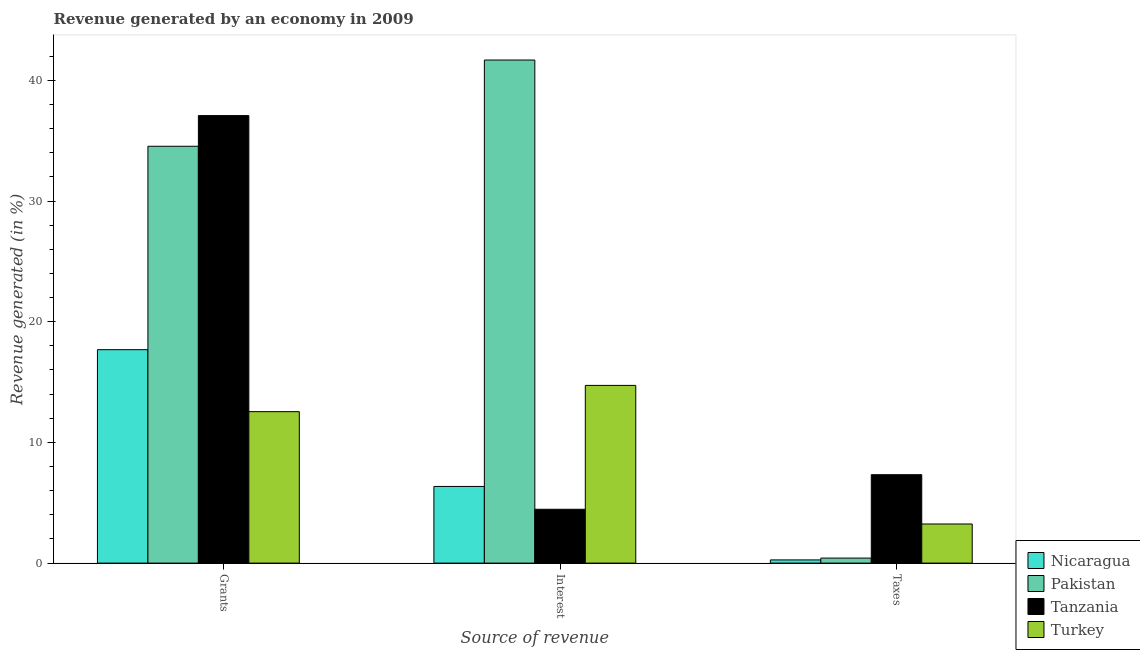How many different coloured bars are there?
Provide a succinct answer. 4. Are the number of bars per tick equal to the number of legend labels?
Your answer should be very brief. Yes. Are the number of bars on each tick of the X-axis equal?
Keep it short and to the point. Yes. How many bars are there on the 3rd tick from the right?
Your answer should be compact. 4. What is the label of the 3rd group of bars from the left?
Ensure brevity in your answer.  Taxes. What is the percentage of revenue generated by taxes in Tanzania?
Your response must be concise. 7.33. Across all countries, what is the maximum percentage of revenue generated by taxes?
Provide a succinct answer. 7.33. Across all countries, what is the minimum percentage of revenue generated by grants?
Provide a succinct answer. 12.55. In which country was the percentage of revenue generated by grants minimum?
Offer a terse response. Turkey. What is the total percentage of revenue generated by interest in the graph?
Keep it short and to the point. 67.22. What is the difference between the percentage of revenue generated by grants in Tanzania and that in Turkey?
Ensure brevity in your answer.  24.53. What is the difference between the percentage of revenue generated by interest in Pakistan and the percentage of revenue generated by taxes in Nicaragua?
Your response must be concise. 41.41. What is the average percentage of revenue generated by interest per country?
Give a very brief answer. 16.8. What is the difference between the percentage of revenue generated by interest and percentage of revenue generated by grants in Pakistan?
Your answer should be compact. 7.14. What is the ratio of the percentage of revenue generated by taxes in Nicaragua to that in Tanzania?
Ensure brevity in your answer.  0.04. Is the percentage of revenue generated by grants in Tanzania less than that in Pakistan?
Provide a short and direct response. No. Is the difference between the percentage of revenue generated by taxes in Turkey and Tanzania greater than the difference between the percentage of revenue generated by interest in Turkey and Tanzania?
Ensure brevity in your answer.  No. What is the difference between the highest and the second highest percentage of revenue generated by taxes?
Keep it short and to the point. 4.08. What is the difference between the highest and the lowest percentage of revenue generated by interest?
Provide a succinct answer. 37.22. Is the sum of the percentage of revenue generated by interest in Turkey and Nicaragua greater than the maximum percentage of revenue generated by grants across all countries?
Provide a succinct answer. No. What does the 1st bar from the left in Taxes represents?
Make the answer very short. Nicaragua. What does the 4th bar from the right in Interest represents?
Keep it short and to the point. Nicaragua. Is it the case that in every country, the sum of the percentage of revenue generated by grants and percentage of revenue generated by interest is greater than the percentage of revenue generated by taxes?
Your response must be concise. Yes. How many bars are there?
Provide a short and direct response. 12. Are all the bars in the graph horizontal?
Your answer should be very brief. No. How many countries are there in the graph?
Ensure brevity in your answer.  4. Does the graph contain grids?
Provide a short and direct response. No. Where does the legend appear in the graph?
Ensure brevity in your answer.  Bottom right. How are the legend labels stacked?
Ensure brevity in your answer.  Vertical. What is the title of the graph?
Make the answer very short. Revenue generated by an economy in 2009. What is the label or title of the X-axis?
Give a very brief answer. Source of revenue. What is the label or title of the Y-axis?
Provide a short and direct response. Revenue generated (in %). What is the Revenue generated (in %) of Nicaragua in Grants?
Ensure brevity in your answer.  17.68. What is the Revenue generated (in %) in Pakistan in Grants?
Provide a succinct answer. 34.54. What is the Revenue generated (in %) of Tanzania in Grants?
Your answer should be compact. 37.08. What is the Revenue generated (in %) in Turkey in Grants?
Provide a short and direct response. 12.55. What is the Revenue generated (in %) of Nicaragua in Interest?
Your answer should be very brief. 6.35. What is the Revenue generated (in %) in Pakistan in Interest?
Make the answer very short. 41.68. What is the Revenue generated (in %) of Tanzania in Interest?
Offer a terse response. 4.46. What is the Revenue generated (in %) in Turkey in Interest?
Offer a very short reply. 14.72. What is the Revenue generated (in %) in Nicaragua in Taxes?
Provide a succinct answer. 0.27. What is the Revenue generated (in %) in Pakistan in Taxes?
Keep it short and to the point. 0.42. What is the Revenue generated (in %) of Tanzania in Taxes?
Keep it short and to the point. 7.33. What is the Revenue generated (in %) in Turkey in Taxes?
Your response must be concise. 3.24. Across all Source of revenue, what is the maximum Revenue generated (in %) in Nicaragua?
Provide a short and direct response. 17.68. Across all Source of revenue, what is the maximum Revenue generated (in %) of Pakistan?
Keep it short and to the point. 41.68. Across all Source of revenue, what is the maximum Revenue generated (in %) in Tanzania?
Keep it short and to the point. 37.08. Across all Source of revenue, what is the maximum Revenue generated (in %) in Turkey?
Offer a terse response. 14.72. Across all Source of revenue, what is the minimum Revenue generated (in %) in Nicaragua?
Keep it short and to the point. 0.27. Across all Source of revenue, what is the minimum Revenue generated (in %) of Pakistan?
Ensure brevity in your answer.  0.42. Across all Source of revenue, what is the minimum Revenue generated (in %) in Tanzania?
Provide a succinct answer. 4.46. Across all Source of revenue, what is the minimum Revenue generated (in %) of Turkey?
Keep it short and to the point. 3.24. What is the total Revenue generated (in %) in Nicaragua in the graph?
Offer a very short reply. 24.3. What is the total Revenue generated (in %) in Pakistan in the graph?
Give a very brief answer. 76.63. What is the total Revenue generated (in %) in Tanzania in the graph?
Keep it short and to the point. 48.86. What is the total Revenue generated (in %) in Turkey in the graph?
Your answer should be very brief. 30.51. What is the difference between the Revenue generated (in %) in Nicaragua in Grants and that in Interest?
Your answer should be very brief. 11.33. What is the difference between the Revenue generated (in %) of Pakistan in Grants and that in Interest?
Your answer should be very brief. -7.14. What is the difference between the Revenue generated (in %) of Tanzania in Grants and that in Interest?
Give a very brief answer. 32.62. What is the difference between the Revenue generated (in %) in Turkey in Grants and that in Interest?
Make the answer very short. -2.17. What is the difference between the Revenue generated (in %) in Nicaragua in Grants and that in Taxes?
Give a very brief answer. 17.42. What is the difference between the Revenue generated (in %) of Pakistan in Grants and that in Taxes?
Provide a succinct answer. 34.12. What is the difference between the Revenue generated (in %) in Tanzania in Grants and that in Taxes?
Your answer should be compact. 29.75. What is the difference between the Revenue generated (in %) of Turkey in Grants and that in Taxes?
Your answer should be compact. 9.31. What is the difference between the Revenue generated (in %) in Nicaragua in Interest and that in Taxes?
Offer a very short reply. 6.09. What is the difference between the Revenue generated (in %) of Pakistan in Interest and that in Taxes?
Your response must be concise. 41.26. What is the difference between the Revenue generated (in %) of Tanzania in Interest and that in Taxes?
Your answer should be compact. -2.86. What is the difference between the Revenue generated (in %) of Turkey in Interest and that in Taxes?
Provide a short and direct response. 11.48. What is the difference between the Revenue generated (in %) of Nicaragua in Grants and the Revenue generated (in %) of Pakistan in Interest?
Ensure brevity in your answer.  -24. What is the difference between the Revenue generated (in %) of Nicaragua in Grants and the Revenue generated (in %) of Tanzania in Interest?
Keep it short and to the point. 13.22. What is the difference between the Revenue generated (in %) of Nicaragua in Grants and the Revenue generated (in %) of Turkey in Interest?
Your response must be concise. 2.96. What is the difference between the Revenue generated (in %) in Pakistan in Grants and the Revenue generated (in %) in Tanzania in Interest?
Offer a very short reply. 30.08. What is the difference between the Revenue generated (in %) of Pakistan in Grants and the Revenue generated (in %) of Turkey in Interest?
Make the answer very short. 19.81. What is the difference between the Revenue generated (in %) of Tanzania in Grants and the Revenue generated (in %) of Turkey in Interest?
Your response must be concise. 22.35. What is the difference between the Revenue generated (in %) in Nicaragua in Grants and the Revenue generated (in %) in Pakistan in Taxes?
Give a very brief answer. 17.27. What is the difference between the Revenue generated (in %) of Nicaragua in Grants and the Revenue generated (in %) of Tanzania in Taxes?
Your answer should be very brief. 10.36. What is the difference between the Revenue generated (in %) in Nicaragua in Grants and the Revenue generated (in %) in Turkey in Taxes?
Your answer should be compact. 14.44. What is the difference between the Revenue generated (in %) of Pakistan in Grants and the Revenue generated (in %) of Tanzania in Taxes?
Provide a short and direct response. 27.21. What is the difference between the Revenue generated (in %) of Pakistan in Grants and the Revenue generated (in %) of Turkey in Taxes?
Your response must be concise. 31.29. What is the difference between the Revenue generated (in %) in Tanzania in Grants and the Revenue generated (in %) in Turkey in Taxes?
Offer a terse response. 33.84. What is the difference between the Revenue generated (in %) of Nicaragua in Interest and the Revenue generated (in %) of Pakistan in Taxes?
Offer a terse response. 5.94. What is the difference between the Revenue generated (in %) of Nicaragua in Interest and the Revenue generated (in %) of Tanzania in Taxes?
Give a very brief answer. -0.97. What is the difference between the Revenue generated (in %) of Nicaragua in Interest and the Revenue generated (in %) of Turkey in Taxes?
Make the answer very short. 3.11. What is the difference between the Revenue generated (in %) in Pakistan in Interest and the Revenue generated (in %) in Tanzania in Taxes?
Provide a succinct answer. 34.36. What is the difference between the Revenue generated (in %) of Pakistan in Interest and the Revenue generated (in %) of Turkey in Taxes?
Give a very brief answer. 38.44. What is the difference between the Revenue generated (in %) of Tanzania in Interest and the Revenue generated (in %) of Turkey in Taxes?
Your response must be concise. 1.22. What is the average Revenue generated (in %) in Nicaragua per Source of revenue?
Ensure brevity in your answer.  8.1. What is the average Revenue generated (in %) in Pakistan per Source of revenue?
Provide a short and direct response. 25.54. What is the average Revenue generated (in %) in Tanzania per Source of revenue?
Your answer should be compact. 16.29. What is the average Revenue generated (in %) of Turkey per Source of revenue?
Provide a short and direct response. 10.17. What is the difference between the Revenue generated (in %) of Nicaragua and Revenue generated (in %) of Pakistan in Grants?
Your answer should be compact. -16.85. What is the difference between the Revenue generated (in %) of Nicaragua and Revenue generated (in %) of Tanzania in Grants?
Your answer should be very brief. -19.39. What is the difference between the Revenue generated (in %) of Nicaragua and Revenue generated (in %) of Turkey in Grants?
Your answer should be compact. 5.13. What is the difference between the Revenue generated (in %) in Pakistan and Revenue generated (in %) in Tanzania in Grants?
Your answer should be very brief. -2.54. What is the difference between the Revenue generated (in %) in Pakistan and Revenue generated (in %) in Turkey in Grants?
Provide a short and direct response. 21.99. What is the difference between the Revenue generated (in %) in Tanzania and Revenue generated (in %) in Turkey in Grants?
Keep it short and to the point. 24.53. What is the difference between the Revenue generated (in %) of Nicaragua and Revenue generated (in %) of Pakistan in Interest?
Your response must be concise. -35.33. What is the difference between the Revenue generated (in %) in Nicaragua and Revenue generated (in %) in Tanzania in Interest?
Make the answer very short. 1.89. What is the difference between the Revenue generated (in %) in Nicaragua and Revenue generated (in %) in Turkey in Interest?
Give a very brief answer. -8.37. What is the difference between the Revenue generated (in %) of Pakistan and Revenue generated (in %) of Tanzania in Interest?
Provide a succinct answer. 37.22. What is the difference between the Revenue generated (in %) in Pakistan and Revenue generated (in %) in Turkey in Interest?
Your answer should be very brief. 26.96. What is the difference between the Revenue generated (in %) in Tanzania and Revenue generated (in %) in Turkey in Interest?
Your answer should be very brief. -10.26. What is the difference between the Revenue generated (in %) in Nicaragua and Revenue generated (in %) in Pakistan in Taxes?
Give a very brief answer. -0.15. What is the difference between the Revenue generated (in %) of Nicaragua and Revenue generated (in %) of Tanzania in Taxes?
Make the answer very short. -7.06. What is the difference between the Revenue generated (in %) in Nicaragua and Revenue generated (in %) in Turkey in Taxes?
Ensure brevity in your answer.  -2.98. What is the difference between the Revenue generated (in %) in Pakistan and Revenue generated (in %) in Tanzania in Taxes?
Offer a terse response. -6.91. What is the difference between the Revenue generated (in %) of Pakistan and Revenue generated (in %) of Turkey in Taxes?
Make the answer very short. -2.83. What is the difference between the Revenue generated (in %) in Tanzania and Revenue generated (in %) in Turkey in Taxes?
Offer a very short reply. 4.08. What is the ratio of the Revenue generated (in %) of Nicaragua in Grants to that in Interest?
Your answer should be very brief. 2.78. What is the ratio of the Revenue generated (in %) in Pakistan in Grants to that in Interest?
Give a very brief answer. 0.83. What is the ratio of the Revenue generated (in %) in Tanzania in Grants to that in Interest?
Your answer should be compact. 8.31. What is the ratio of the Revenue generated (in %) of Turkey in Grants to that in Interest?
Your response must be concise. 0.85. What is the ratio of the Revenue generated (in %) of Nicaragua in Grants to that in Taxes?
Your answer should be very brief. 66.62. What is the ratio of the Revenue generated (in %) in Pakistan in Grants to that in Taxes?
Offer a terse response. 83. What is the ratio of the Revenue generated (in %) in Tanzania in Grants to that in Taxes?
Give a very brief answer. 5.06. What is the ratio of the Revenue generated (in %) of Turkey in Grants to that in Taxes?
Ensure brevity in your answer.  3.87. What is the ratio of the Revenue generated (in %) of Nicaragua in Interest to that in Taxes?
Provide a succinct answer. 23.93. What is the ratio of the Revenue generated (in %) of Pakistan in Interest to that in Taxes?
Provide a short and direct response. 100.17. What is the ratio of the Revenue generated (in %) in Tanzania in Interest to that in Taxes?
Offer a very short reply. 0.61. What is the ratio of the Revenue generated (in %) in Turkey in Interest to that in Taxes?
Your answer should be compact. 4.54. What is the difference between the highest and the second highest Revenue generated (in %) of Nicaragua?
Ensure brevity in your answer.  11.33. What is the difference between the highest and the second highest Revenue generated (in %) of Pakistan?
Keep it short and to the point. 7.14. What is the difference between the highest and the second highest Revenue generated (in %) in Tanzania?
Offer a terse response. 29.75. What is the difference between the highest and the second highest Revenue generated (in %) of Turkey?
Your answer should be very brief. 2.17. What is the difference between the highest and the lowest Revenue generated (in %) of Nicaragua?
Ensure brevity in your answer.  17.42. What is the difference between the highest and the lowest Revenue generated (in %) of Pakistan?
Ensure brevity in your answer.  41.26. What is the difference between the highest and the lowest Revenue generated (in %) of Tanzania?
Offer a terse response. 32.62. What is the difference between the highest and the lowest Revenue generated (in %) in Turkey?
Make the answer very short. 11.48. 